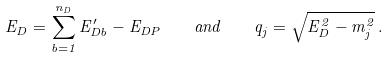Convert formula to latex. <formula><loc_0><loc_0><loc_500><loc_500>E _ { D } = \sum _ { b = 1 } ^ { n _ { D } } E _ { D b } ^ { \prime } - E _ { D P } \quad a n d \quad q _ { j } = \sqrt { E _ { D } ^ { 2 } - m _ { j } ^ { 2 } } \, .</formula> 